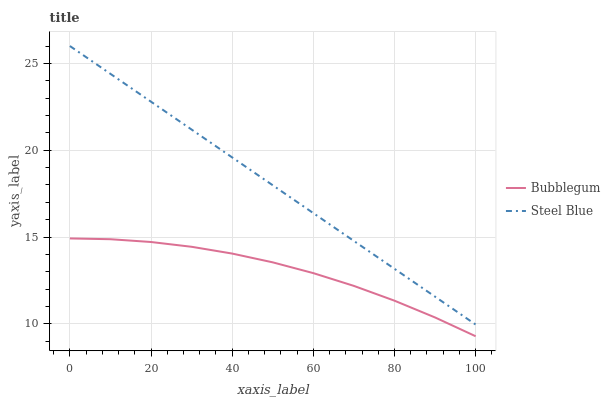Does Bubblegum have the minimum area under the curve?
Answer yes or no. Yes. Does Steel Blue have the maximum area under the curve?
Answer yes or no. Yes. Does Bubblegum have the maximum area under the curve?
Answer yes or no. No. Is Steel Blue the smoothest?
Answer yes or no. Yes. Is Bubblegum the roughest?
Answer yes or no. Yes. Is Bubblegum the smoothest?
Answer yes or no. No. Does Bubblegum have the lowest value?
Answer yes or no. Yes. Does Steel Blue have the highest value?
Answer yes or no. Yes. Does Bubblegum have the highest value?
Answer yes or no. No. Is Bubblegum less than Steel Blue?
Answer yes or no. Yes. Is Steel Blue greater than Bubblegum?
Answer yes or no. Yes. Does Bubblegum intersect Steel Blue?
Answer yes or no. No. 